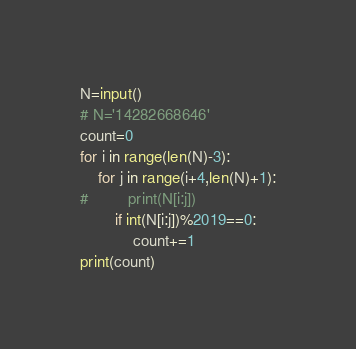Convert code to text. <code><loc_0><loc_0><loc_500><loc_500><_Python_>N=input()
# N='14282668646'
count=0
for i in range(len(N)-3):
    for j in range(i+4,len(N)+1):
#         print(N[i:j])
        if int(N[i:j])%2019==0:
            count+=1
print(count)</code> 